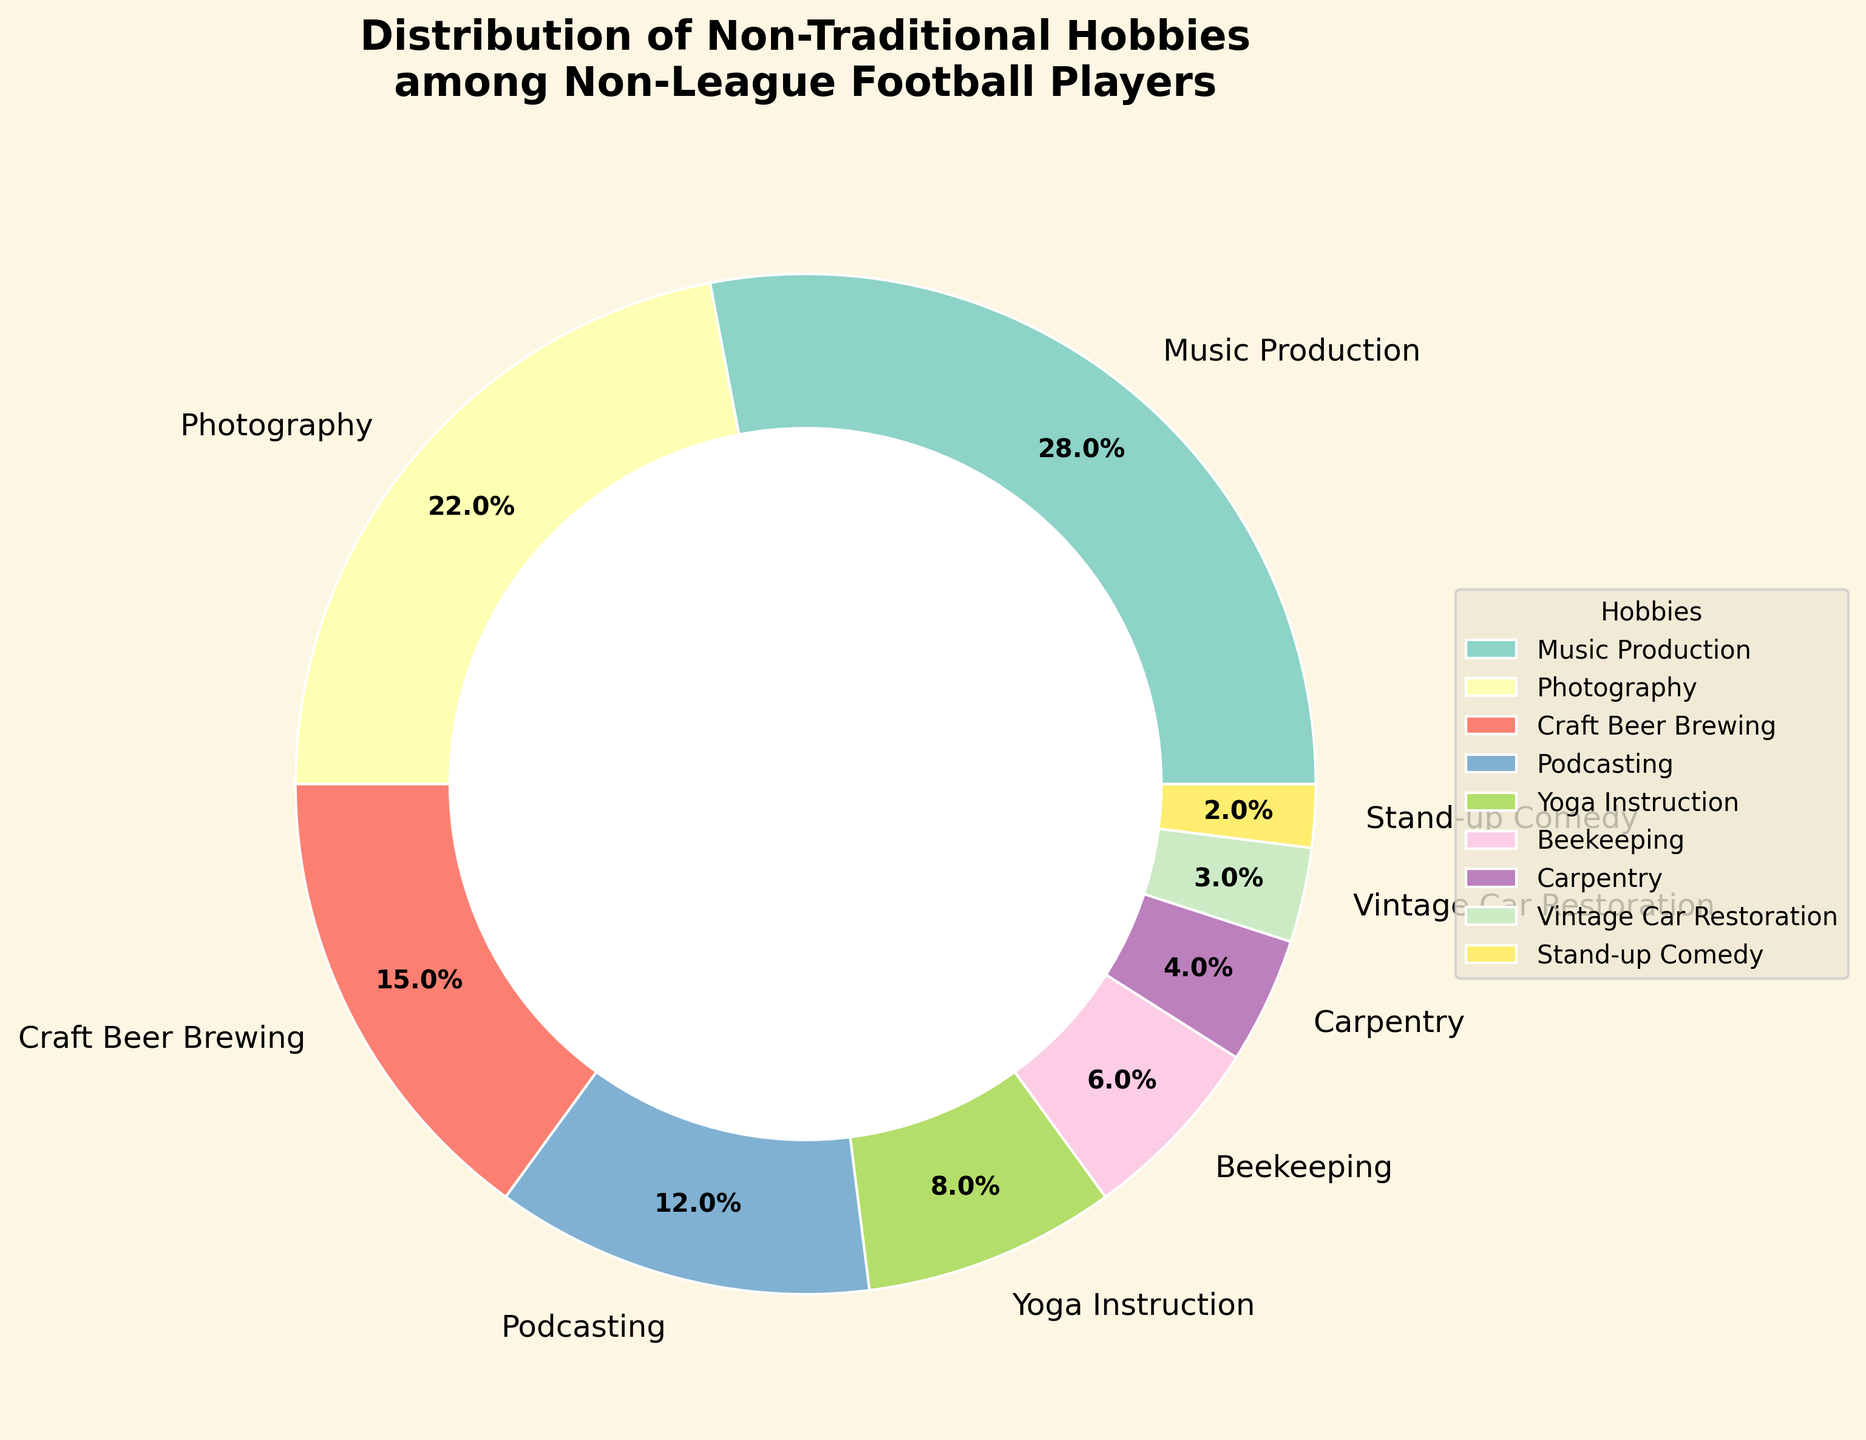What is the most popular non-traditional hobby among non-league football players? By looking at the largest wedge in the pie chart, we can see that 'Music Production' has the highest percentage.
Answer: Music Production What is the combined percentage of players who are into 'Craft Beer Brewing' and 'Podcasting'? Sum the percentages for 'Craft Beer Brewing' (15%) and 'Podcasting' (12%). Therefore, 15% + 12% = 27%.
Answer: 27% Which hobby is less popular, 'Beekeeping' or 'Yoga Instruction'? Comparing the sizes of the wedges for 'Beekeeping' and 'Yoga Instruction', we see that 'Beekeeping' (6%) is smaller than 'Yoga Instruction' (8%), making it less popular.
Answer: Beekeeping By how much does 'Photography' exceed 'Podcasting' in terms of percentage? Subtract the percentage of 'Podcasting' (12%) from 'Photography' (22%). Therefore, 22% - 12% = 10%.
Answer: 10% If we combine 'Beekeeping', 'Carpentry', and 'Vintage Car Restoration', what is their total percentage? Sum the percentages of 'Beekeeping' (6%), 'Carpentry' (4%), and 'Vintage Car Restoration' (3%). Therefore, 6% + 4% + 3% = 13%.
Answer: 13% How many more players are interested in 'Music Production' than in 'Stand-up Comedy'? Subtract the percentage of 'Stand-up Comedy' (2%) from 'Music Production' (28%). Therefore, 28% - 2% = 26%.
Answer: 26% Which non-traditional hobby has the smallest percentage among the football players? The smallest wedge or slice in the pie chart belongs to 'Stand-up Comedy' at 2%.
Answer: Stand-up Comedy Which two hobbies combined account for over 50% of the players? By examining the wedges, 'Music Production' (28%) and 'Photography' (22%) together total 50%, and no other pairs exceed this combined percentage.
Answer: Music Production and Photography What is the difference in percentage between 'Carpentry' and 'Yoga Instruction'? Subtract the percentage for 'Carpentry' (4%) from 'Yoga Instruction' (8%). Therefore, 8% - 4% = 4%.
Answer: 4% What is the average percentage for the hobbies 'Stand-up Comedy', 'Vintage Car Restoration', and 'Carpentry'? Sum the percentages (2% + 3% + 4%) and divide by the number of hobbies (3). Therefore, (2% + 3% + 4%)/3 = 9%/3 = 3%.
Answer: 3% 